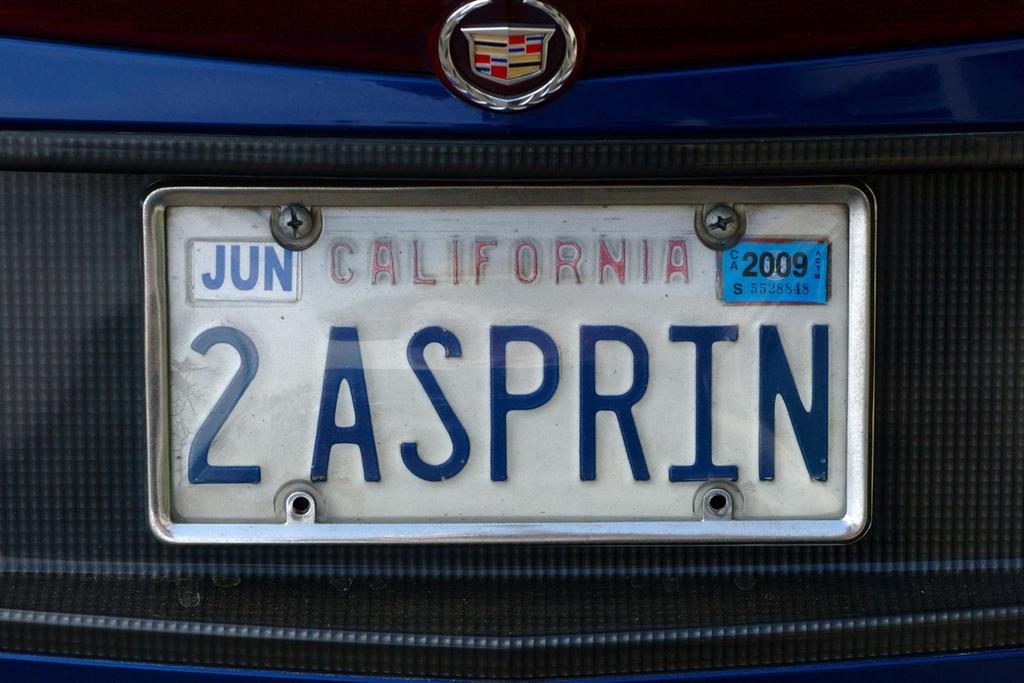What state issued this license plate?
Your answer should be compact. California. What month was the plate issued?
Offer a very short reply. June. 